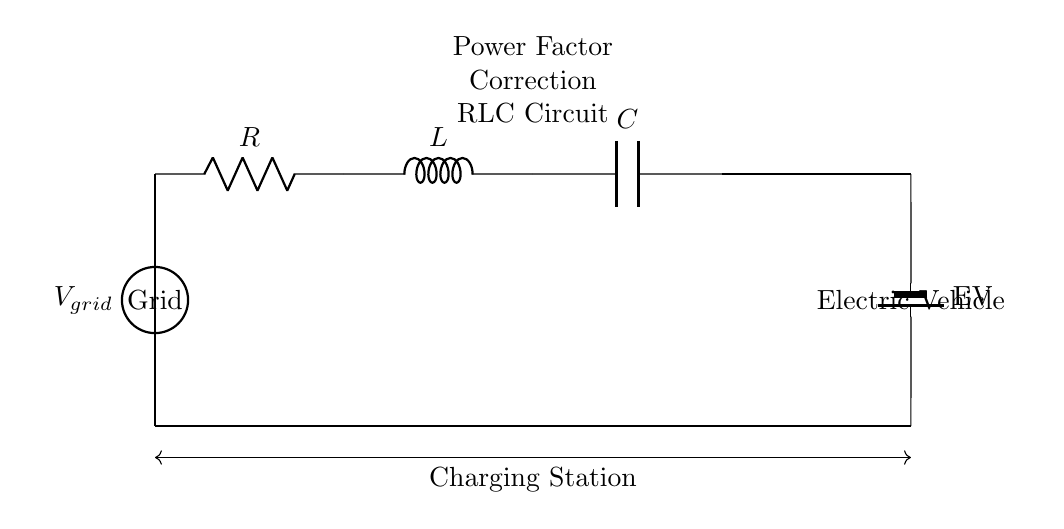What is the main purpose of this circuit? The main purpose of this circuit is power factor correction for the charging station, which improves the efficiency of energy transfer from the grid to the electric vehicle.
Answer: Power factor correction What components are present in this circuit? The components in this circuit include a resistor, inductor, and capacitor, which are essential for creating the RLC circuit.
Answer: Resistor, inductor, capacitor What is the role of the capacitor in this circuit? The capacitor stores and releases energy, helping to improve the circuit's power factor by reducing reactive power.
Answer: Energy storage Which components contribute to the circuit's impedance? The impedance of the circuit is contributed by the combination of the resistor, inductor, and capacitor, as they all influence overall circuit behavior.
Answer: Resistor, inductor, capacitor How does the inductor affect the circuit's response? The inductor introduces inductive reactance, which causes the circuit to store energy in a magnetic field, affecting the overall impedance and phase angle of the current.
Answer: Inductive reactance What happens to the power factor if the load increases? If the load increases, the power factor may decrease due to increased reactive power, which can lead to inefficiencies in energy transfer.
Answer: Decreases What does "RLC" stand for in this circuit context? "RLC" stands for resistor, inductor, and capacitor, which are the fundamental components that make up this power factor correction circuit.
Answer: Resistor, inductor, capacitor 